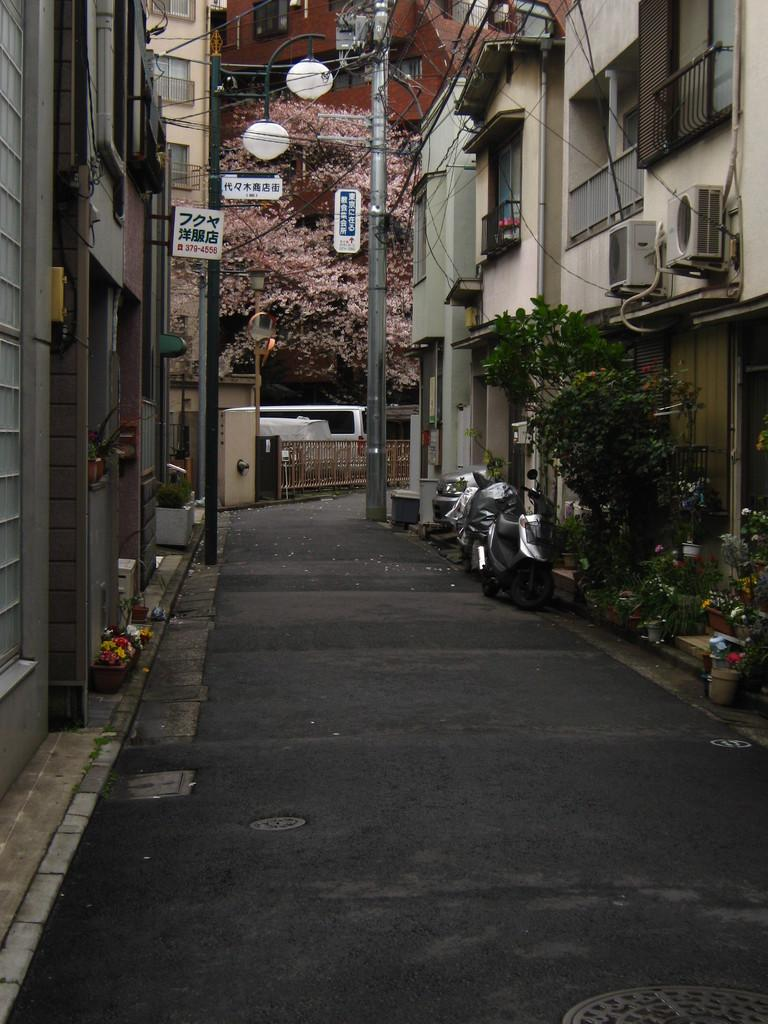What structures are located on both sides of the image? There are buildings on the right and left sides of the image. What vertical structures can be seen in the image? There are utility poles in the image. What type of natural elements are present in the image? There are trees in the image. What is in the middle of the buildings? There is a road in the middle of the buildings. What are the vehicles doing in the image? The vehicles are parked on the road. What type of voyage is depicted in the image? There is no voyage depicted in the image; it shows a scene with buildings, utility poles, trees, a road, and parked vehicles. 